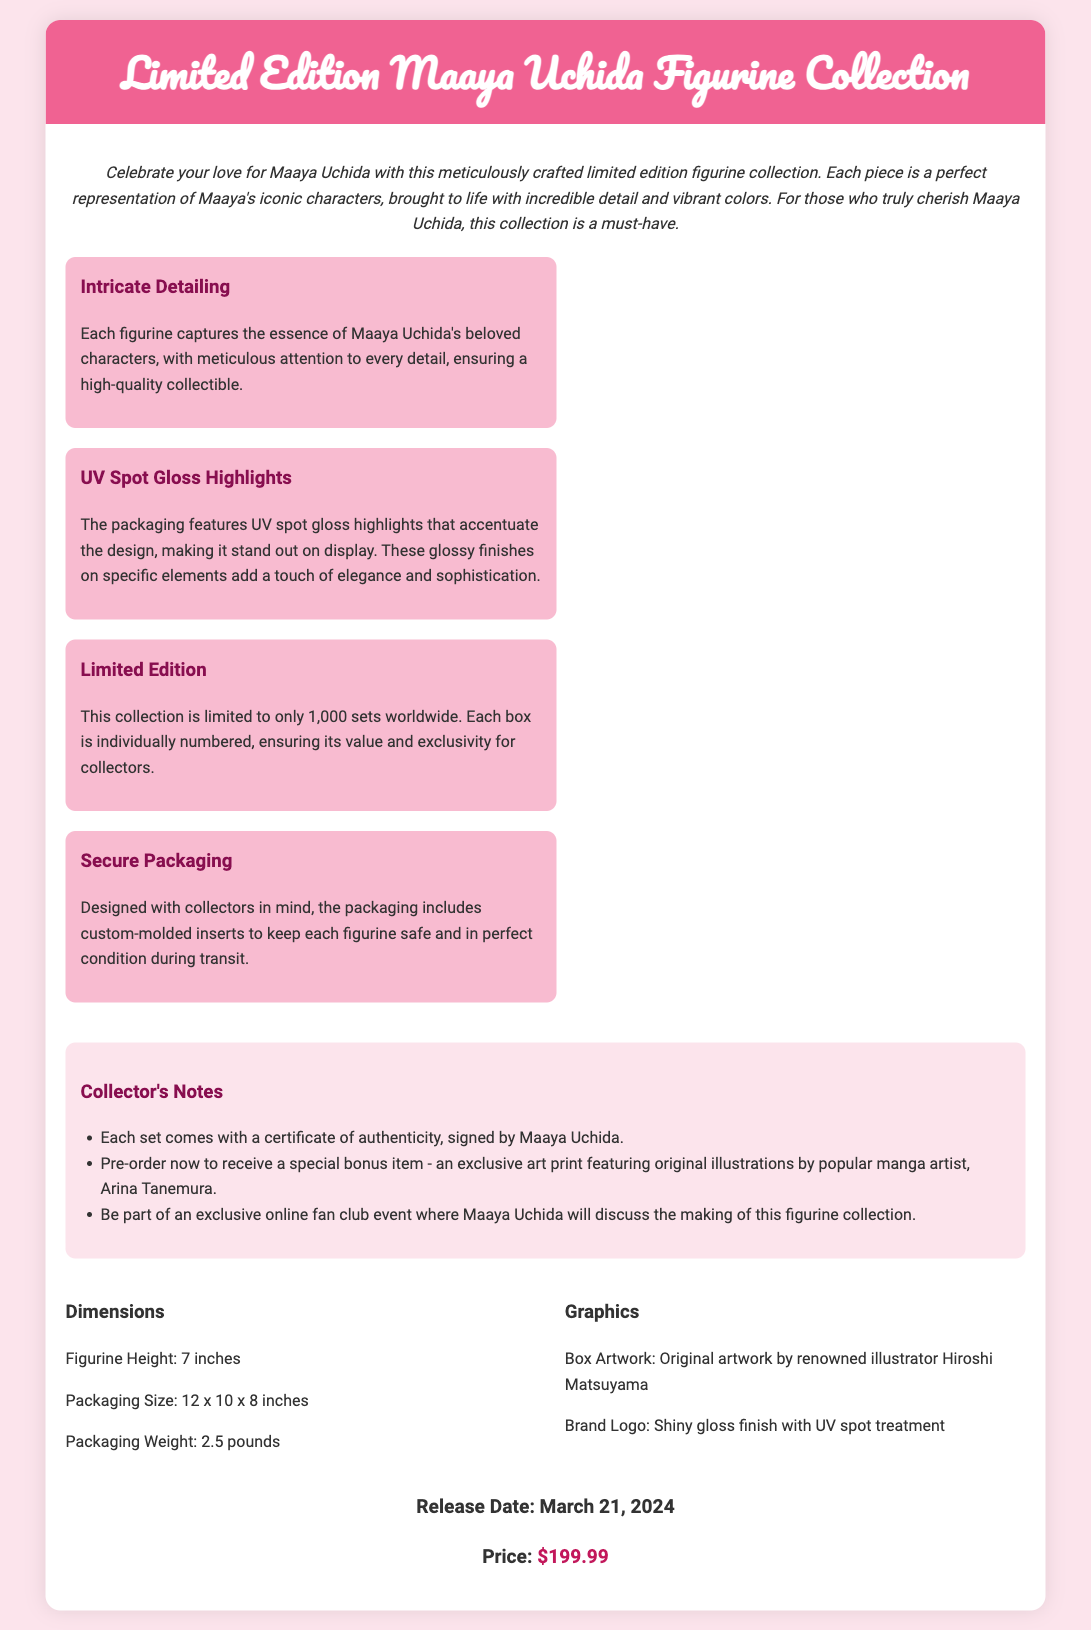What is the release date of the figurine collection? The document states that the release date is specifically mentioned as March 21, 2024.
Answer: March 21, 2024 How many sets of the collection are available worldwide? The document clearly mentions that the collection is limited to only 1,000 sets worldwide.
Answer: 1,000 sets What is included with each figurine set? The document specifies that each set comes with a certificate of authenticity, signed by Maaya Uchida.
Answer: Certificate of authenticity What is a unique feature of the packaging? The document highlights that the packaging features UV spot gloss highlights that accentuate the design.
Answer: UV spot gloss highlights Who illustrated the box artwork? The document identifies that the box artwork is created by renowned illustrator Hiroshi Matsuyama.
Answer: Hiroshi Matsuyama What is the height of the figurine? The document provides the figurine height as part of its specifications, which is 7 inches.
Answer: 7 inches What special item can be received by pre-ordering? The document mentions that pre-ordering the collection includes a special bonus item - an exclusive art print.
Answer: Exclusive art print How many pounds does the packaging weigh? The document lists the packaging weight as 2.5 pounds, providing specific weight information.
Answer: 2.5 pounds 